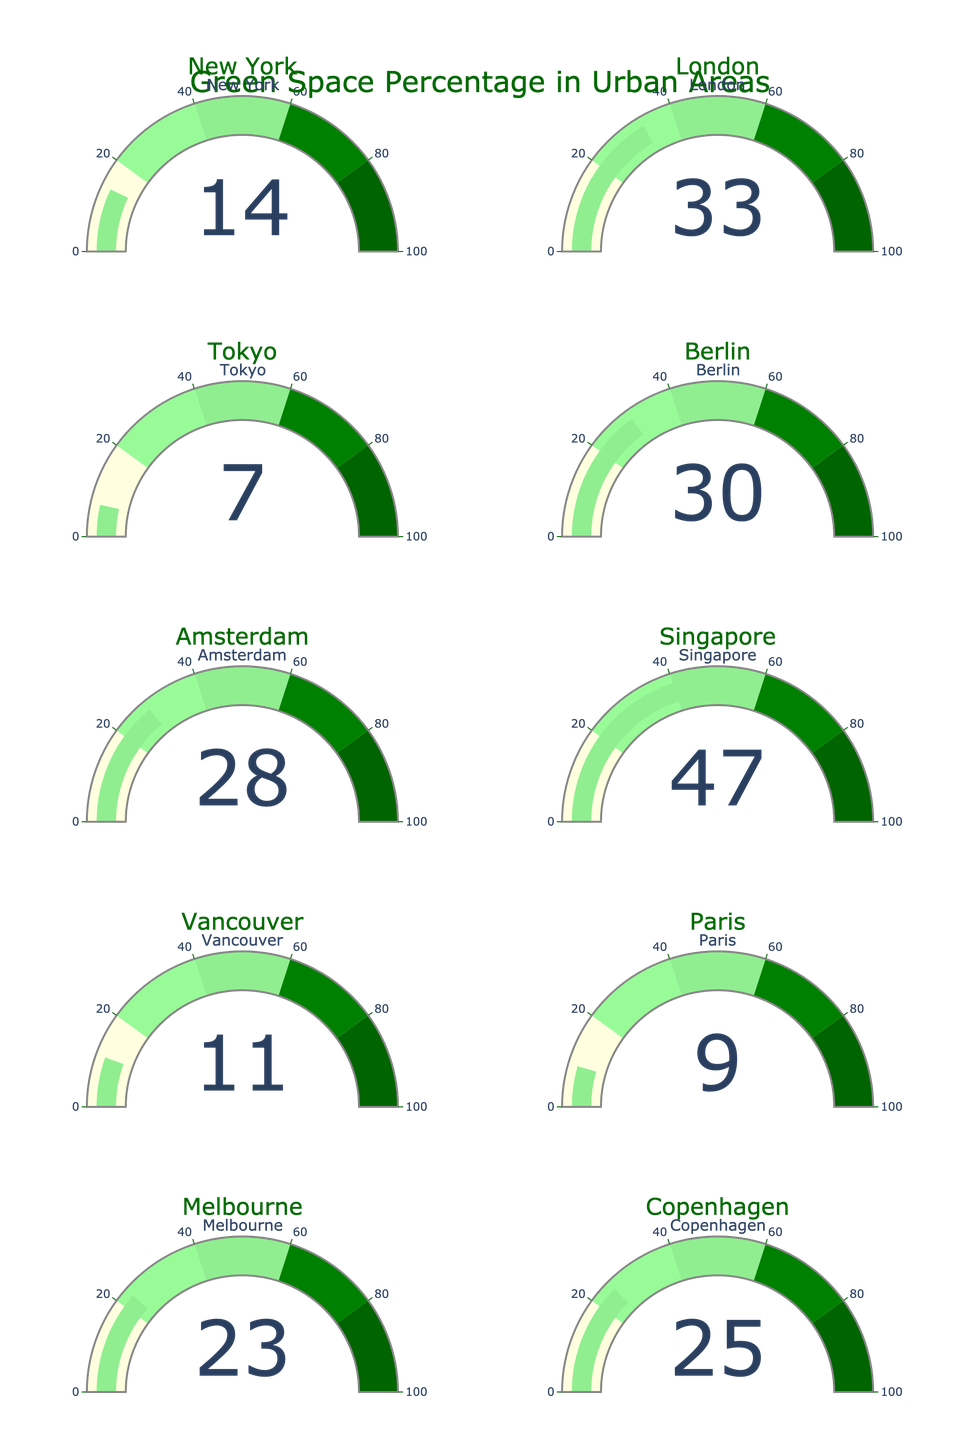What is the percentage of green spaces in New York? The gauge chart shows the percentage for New York directly under the corresponding gauge. The value displayed is 14.
Answer: 14 Which city has the highest percentage of green spaces? From all the gauges, the city with the highest value is Singapore, with a percentage of 47.
Answer: Singapore How many cities have a green space percentage above 20%? By observing each gauge, we find that the cities with green space percentages above 20% are London (33%), Berlin (30%), Amsterdam (28%), Melbourne (23%), and Copenhagen (25%), which total to 5 cities.
Answer: 5 What is the average percentage of green spaces across all cities? Sum all the green space percentages: 14 (New York) + 33 (London) + 7 (Tokyo) + 30 (Berlin) + 28 (Amsterdam) + 47 (Singapore) + 11 (Vancouver) + 9 (Paris) + 23 (Melbourne) + 25 (Copenhagen) = 227. Divide this by the number of cities, 10. 227 / 10 = 22.7.
Answer: 22.7 Which city has the smallest percentage of green space? By reviewing all the gauges, Tokyo has the smallest percentage of green spaces, which is 7.
Answer: Tokyo How does Berlin's green space percentage compare to Melbourne's? Berlin has 30% green space while Melbourne has 23%. Berlin's green space percentage is 7% higher than Melbourne's.
Answer: Berlin has 7% more What is the combined green space percentage of Vancouver and Paris? Vancouver has 11% and Paris has 9%. Their combined percentage is 11 + 9 = 20.
Answer: 20 Is Amsterdam's green space percentage higher than the overall average? Amsterdam has a green space percentage of 28%. The average percentage for all cities is 22.7%. Since 28% is greater than 22.7%, Amsterdam is above the overall average.
Answer: Yes Which cities have a green space percentage between 10% and 30%? By looking at the gauges, the cities that fall in this range are New York (14%), Vancouver (11%), Melbourne (23%), and Copenhagen (25%).
Answer: New York, Vancouver, Melbourne, Copenhagen What is the difference in green space percentages between the city with the highest percentage and the city with the lowest percentage? The city with the highest percentage is Singapore (47%) and the city with the lowest percentage is Tokyo (7%). The difference is 47 - 7 = 40.
Answer: 40 